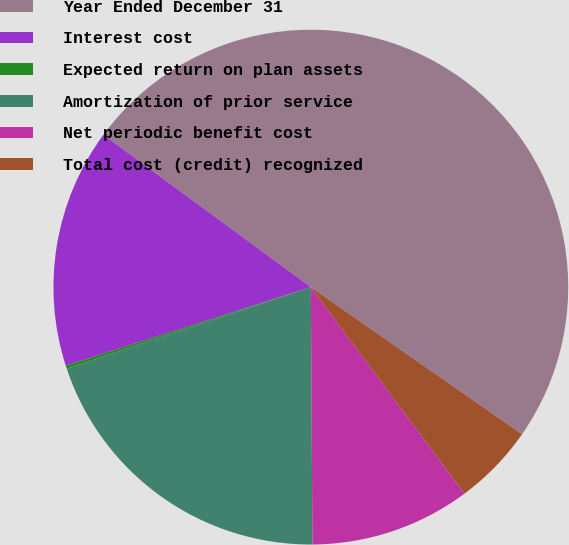Convert chart. <chart><loc_0><loc_0><loc_500><loc_500><pie_chart><fcel>Year Ended December 31<fcel>Interest cost<fcel>Expected return on plan assets<fcel>Amortization of prior service<fcel>Net periodic benefit cost<fcel>Total cost (credit) recognized<nl><fcel>49.61%<fcel>15.02%<fcel>0.2%<fcel>19.96%<fcel>10.08%<fcel>5.14%<nl></chart> 